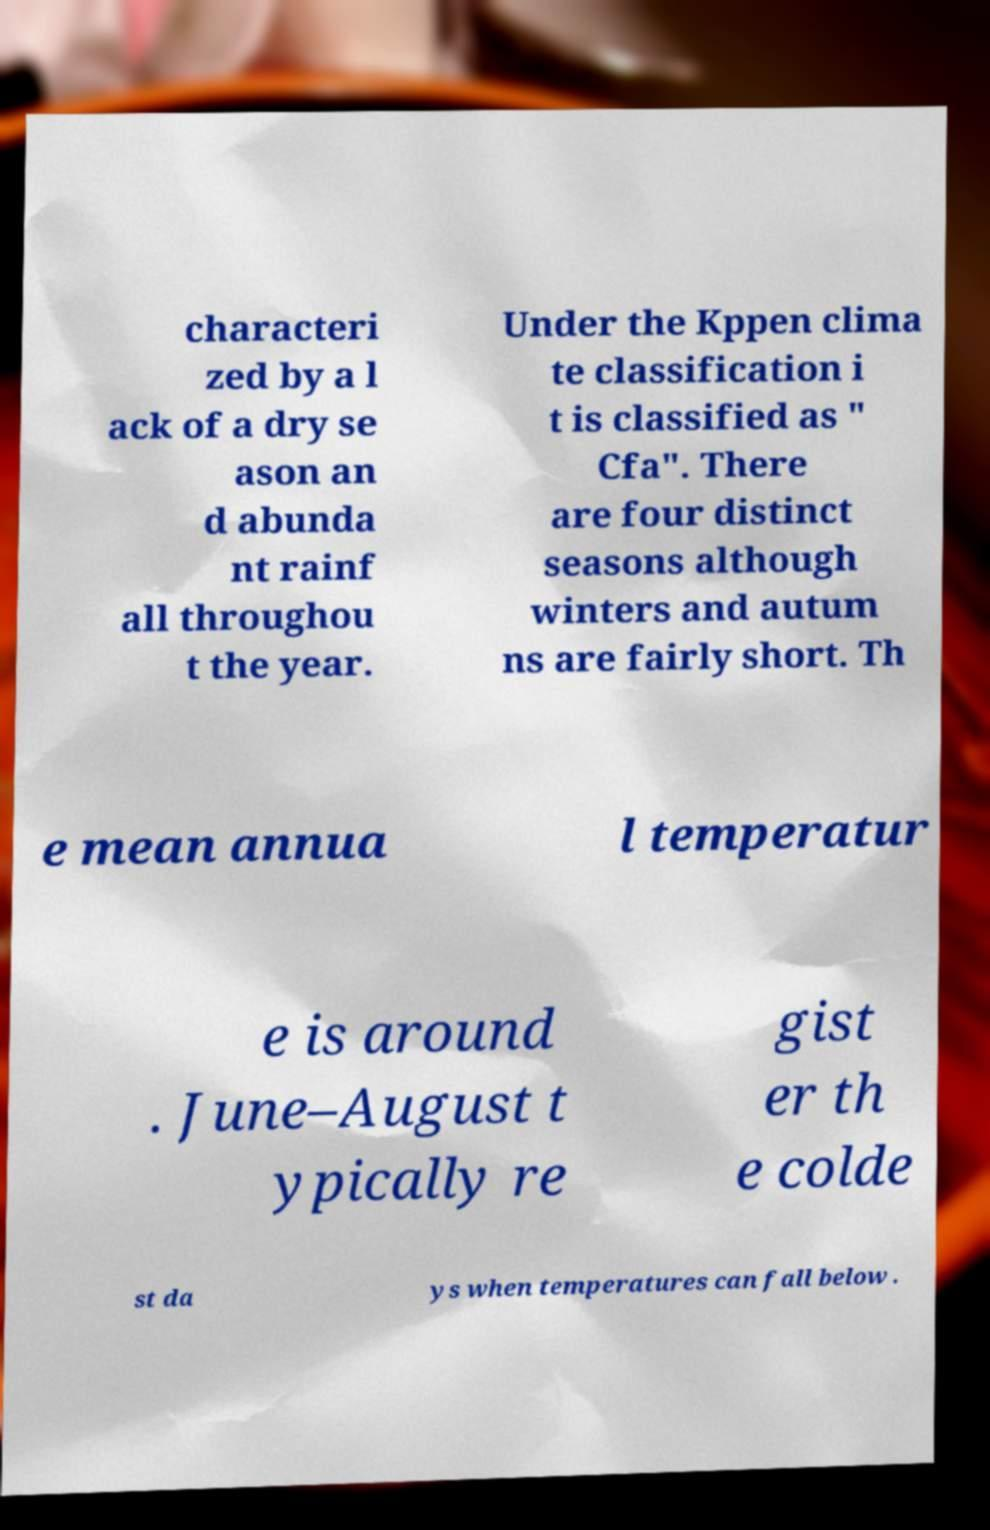What messages or text are displayed in this image? I need them in a readable, typed format. characteri zed by a l ack of a dry se ason an d abunda nt rainf all throughou t the year. Under the Kppen clima te classification i t is classified as " Cfa". There are four distinct seasons although winters and autum ns are fairly short. Th e mean annua l temperatur e is around . June–August t ypically re gist er th e colde st da ys when temperatures can fall below . 